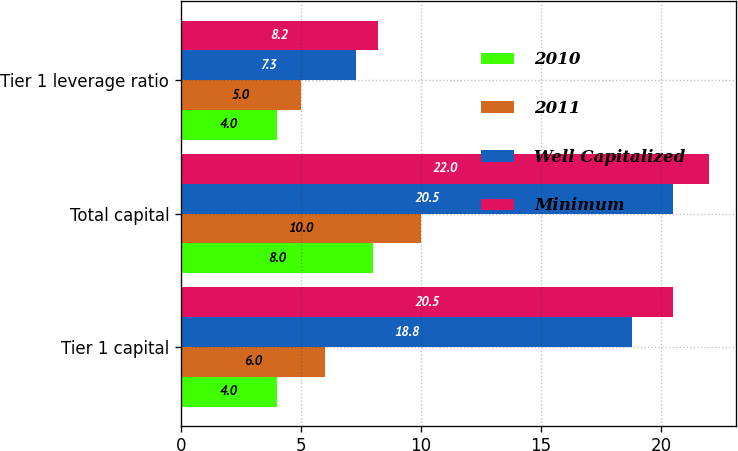Convert chart to OTSL. <chart><loc_0><loc_0><loc_500><loc_500><stacked_bar_chart><ecel><fcel>Tier 1 capital<fcel>Total capital<fcel>Tier 1 leverage ratio<nl><fcel>2010<fcel>4<fcel>8<fcel>4<nl><fcel>2011<fcel>6<fcel>10<fcel>5<nl><fcel>Well Capitalized<fcel>18.8<fcel>20.5<fcel>7.3<nl><fcel>Minimum<fcel>20.5<fcel>22<fcel>8.2<nl></chart> 